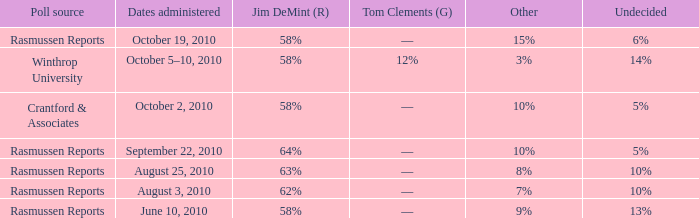When the "other" votes accounted for 9%, what percentage of votes did alvin green receive? 21%. Parse the full table. {'header': ['Poll source', 'Dates administered', 'Jim DeMint (R)', 'Tom Clements (G)', 'Other', 'Undecided'], 'rows': [['Rasmussen Reports', 'October 19, 2010', '58%', '––', '15%', '6%'], ['Winthrop University', 'October 5–10, 2010', '58%', '12%', '3%', '14%'], ['Crantford & Associates', 'October 2, 2010', '58%', '––', '10%', '5%'], ['Rasmussen Reports', 'September 22, 2010', '64%', '––', '10%', '5%'], ['Rasmussen Reports', 'August 25, 2010', '63%', '––', '8%', '10%'], ['Rasmussen Reports', 'August 3, 2010', '62%', '––', '7%', '10%'], ['Rasmussen Reports', 'June 10, 2010', '58%', '––', '9%', '13%']]} 